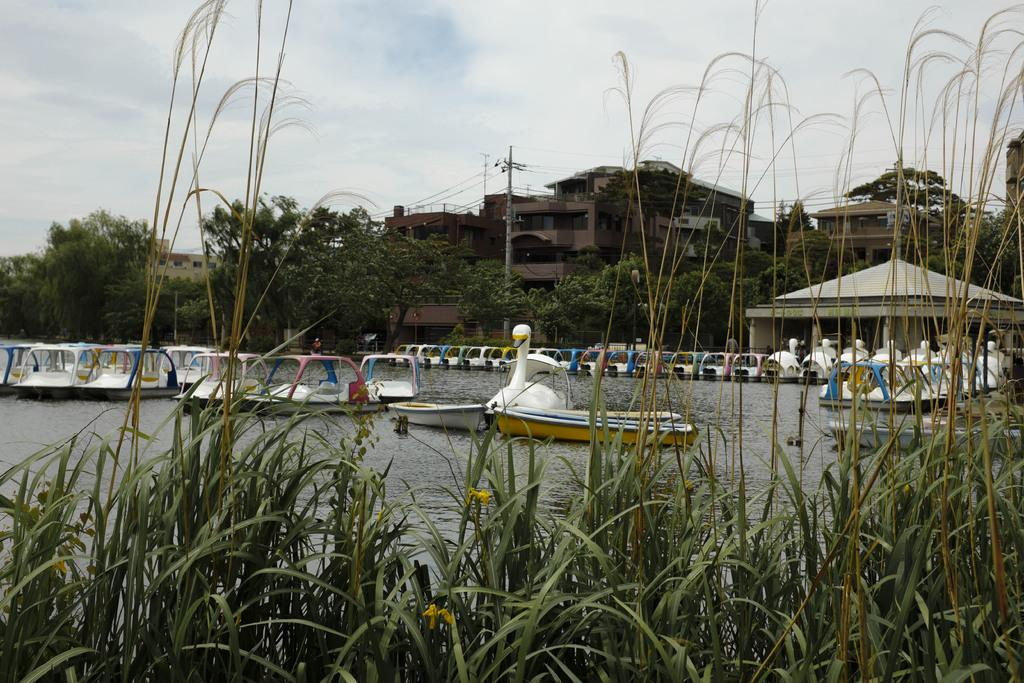What is on the water in the image? There are boats on the water in the image. What can be seen in the background of the image? There are trees, an electric pole, and buildings in the background of the image. What is the color of the trees in the image? The trees are green in color. What is the color of the sky in the image? The sky is blue and white in color. What type of insurance policy is being discussed by the people in the image? There are no people present in the image, and therefore no discussion about insurance policies can be observed. 